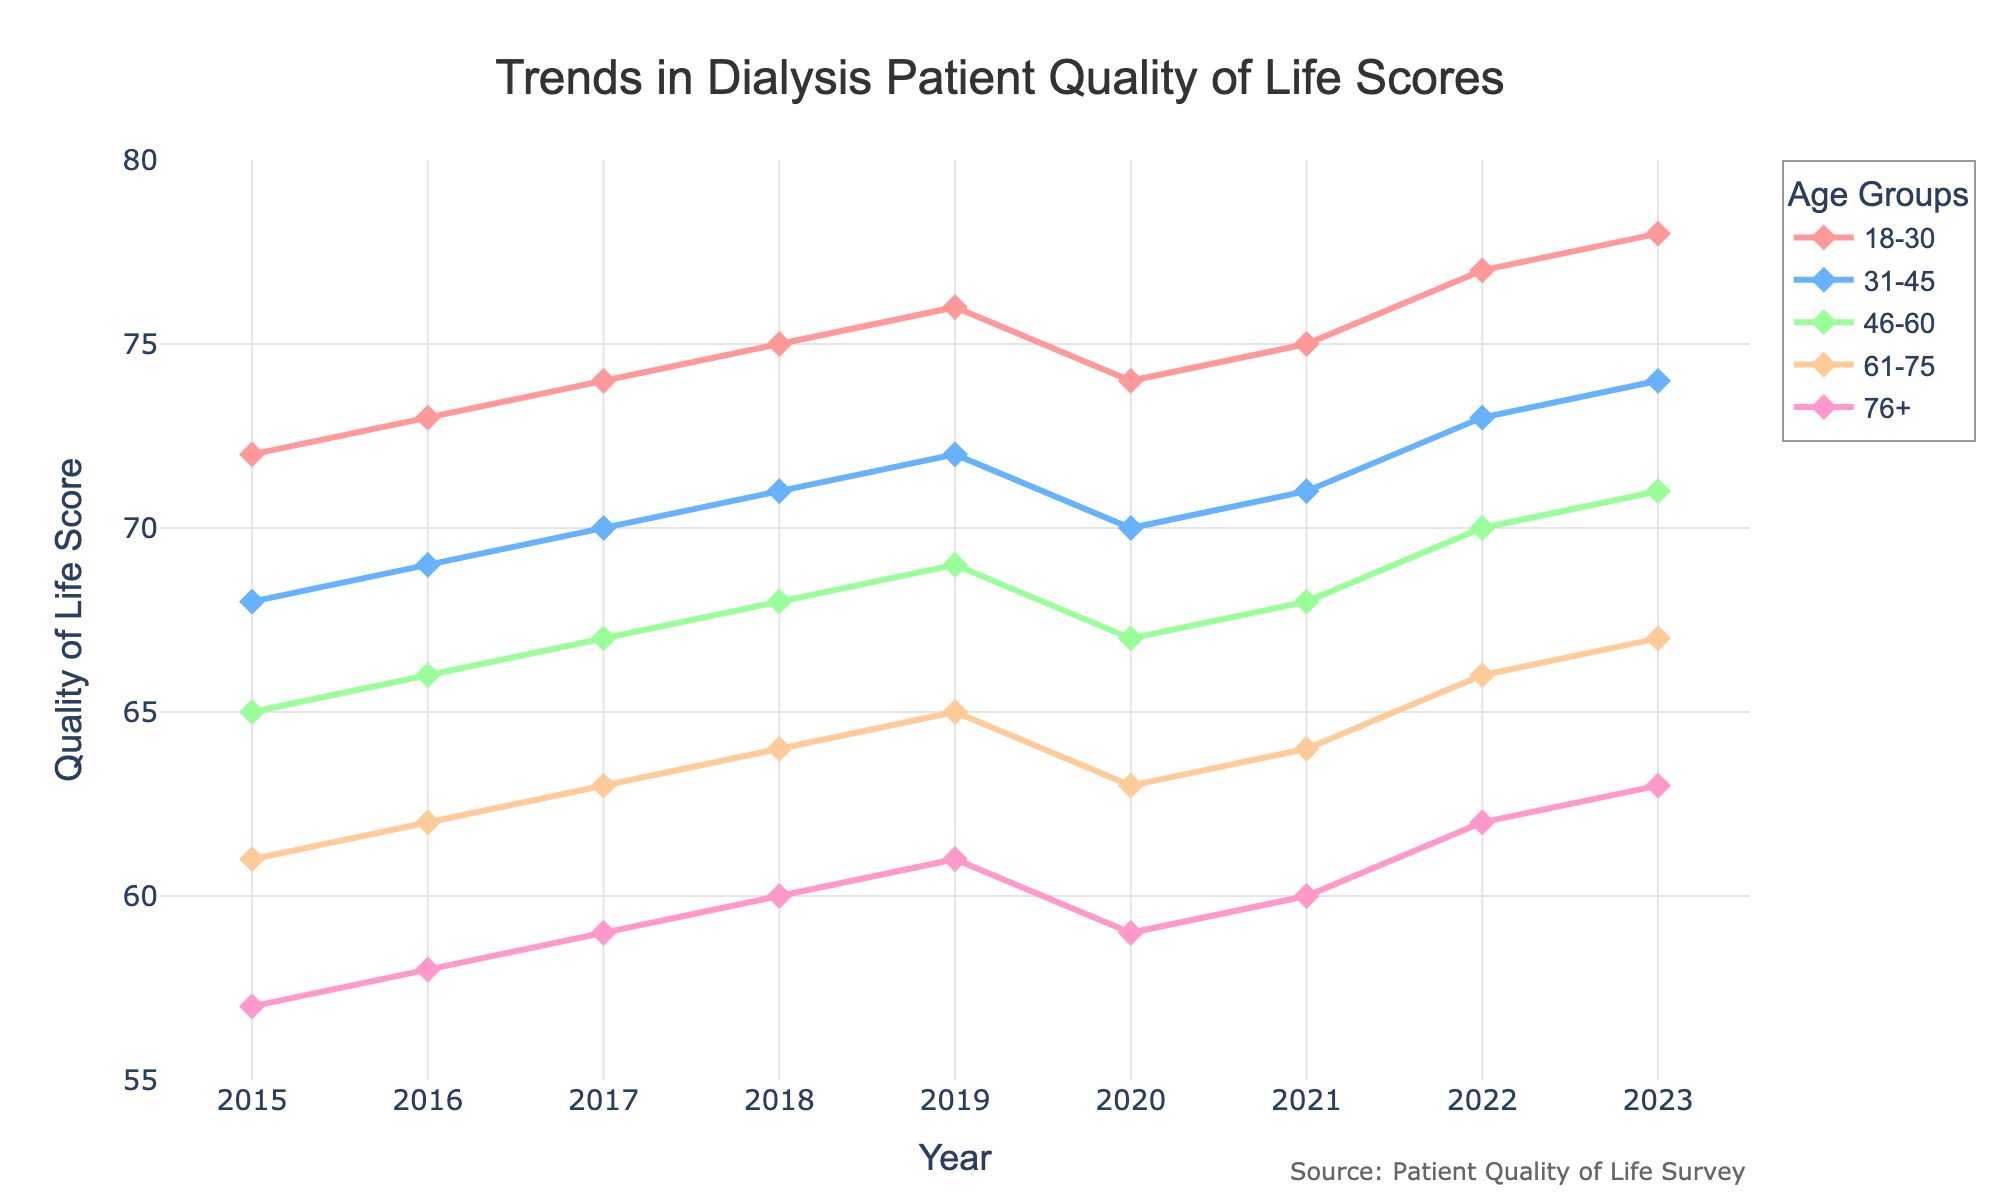What is the trend in the quality of life scores for the 18-30 age group from 2015 to 2023? The plot shows a steady increase in the quality of life scores for the 18-30 age group from 72 in 2015 to 78 in 2023. An upward trend is visible, indicating an overall improvement over time.
Answer: Upward trend In which year did the 31-45 age group experience a decline in quality of life scores? By observing the line plot for the 31-45 age group, it shows a slight dip in scores between 2019 and 2020, where the score decreased from 72 to 70.
Answer: 2020 Which age group had the highest quality of life score in 2023? The chart reveals that the 18-30 age group had the highest quality of life score in 2023 with a score of 78.
Answer: 18-30 What is the difference in quality of life scores between the 61-75 and 76+ age groups in 2017? In 2017, the quality of life score for the 61-75 age group was 63, while for the 76+ age group, it was 59. The difference is 63 - 59 = 4.
Answer: 4 What is the average quality of life score for the 46-60 age group over the period from 2015 to 2023? To find the average score, sum the scores for the 46-60 age group from 2015 to 2023: (65 + 66 + 67 + 68 + 69 + 67 + 68 + 70 + 71) = 611. Divide this by the number of years (9): 611 / 9 ≈ 67.89.
Answer: 67.89 Which age group had the most consistent quality of life scores over the observed period? Consistency can be seen by examining the smallest fluctuations. The 46-60 age group has relatively stable scores ranging from 65 to 71.
Answer: 46-60 In which year did the quality of life score for the 76+ age group reach 60 for the first time? According to the chart, the quality of life score for the 76+ age group first reached 60 in 2018.
Answer: 2018 What is the overall trend in quality of life scores for the 61-75 age group between 2015 and 2023? The quality of life scores for the 61-75 age group show a general upward trend from 61 in 2015 to 67 in 2023.
Answer: Upward trend By how much did the quality of life score for the 31-45 age group change from its lowest point to its highest point between 2015 and 2023? The lowest score for the 31-45 age group was 68 in 2015, and the highest was 74 in 2023. The change is 74 - 68 = 6.
Answer: 6 